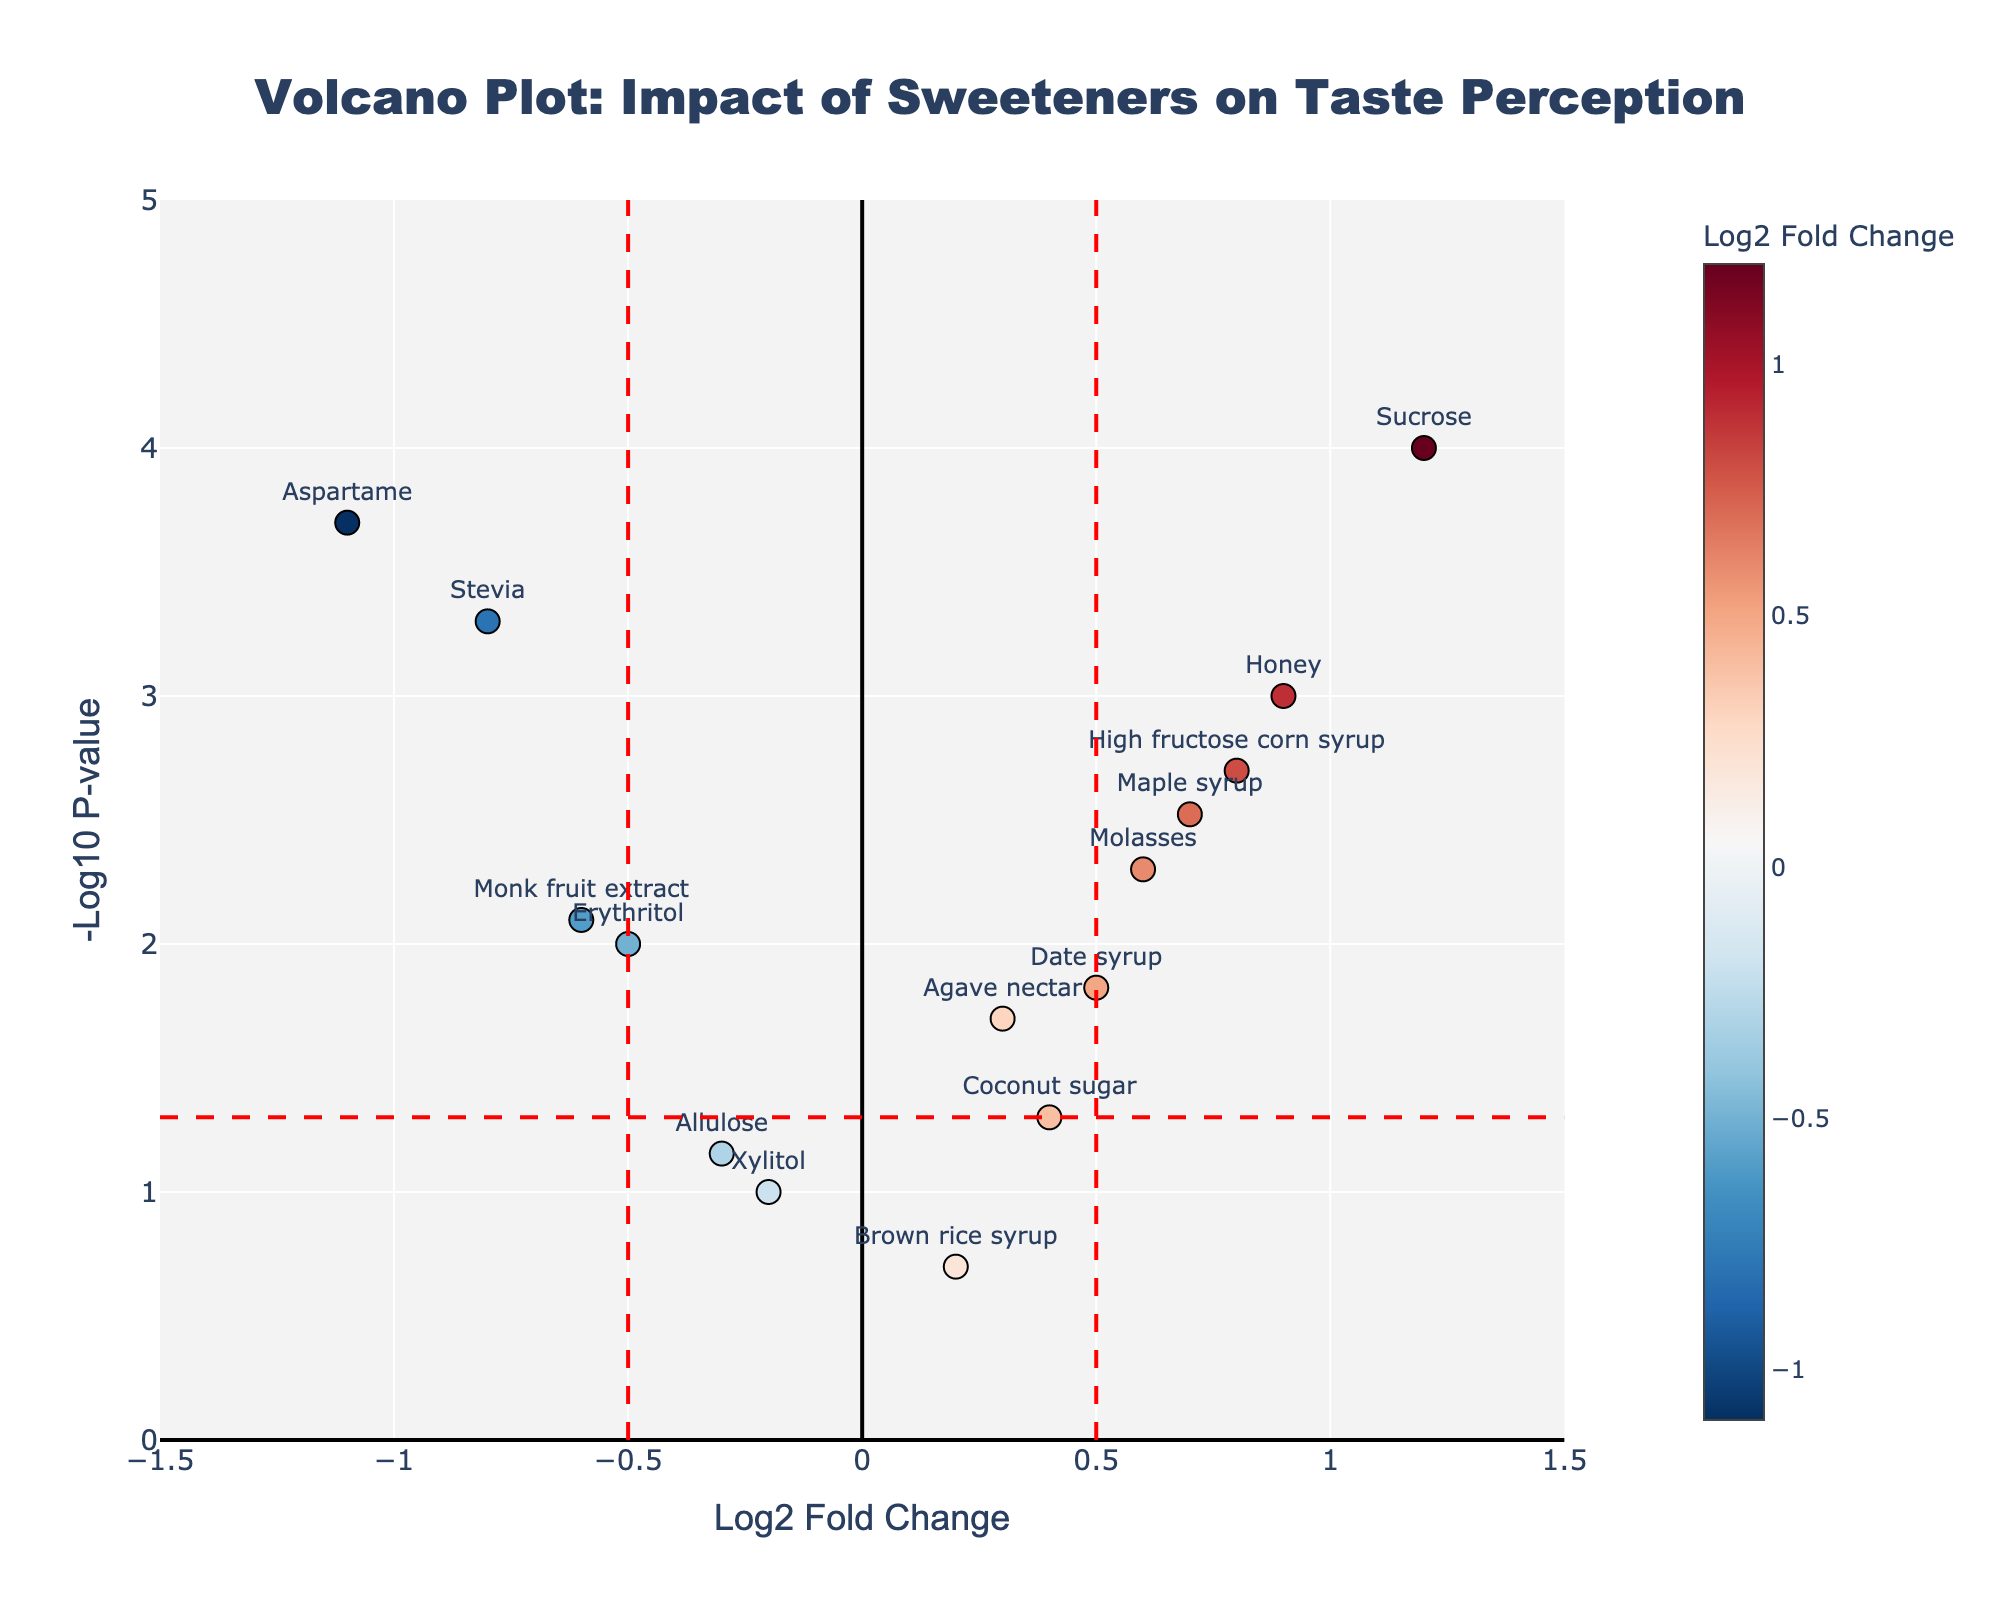What's the highest -log10 p-value shown in the plot? The -log10 p-value is represented on the y-axis. The highest point on this axis will be the maximum value.
Answer: 4 Which sweetener has the most significant positive impact on taste perception? A positive impact on taste perception is shown on the right side (positive log2 fold change) and most significant on the highest point on the y-axis. The sweetener at the highest point on the right side is Sucrose.
Answer: Sucrose Which sweeteners have a statistically significant negative impact on taste perception? Statistically significant points are above the horizontal red dashed line. Those on the left side (negative log2 fold change) are Stevia, Aspartame, Monk fruit extract, and Erythritol.
Answer: Stevia, Aspartame, Monk fruit extract, Erythritol How many sweeteners have a log2 fold change greater than 0.5? Identify points to the right of the vertical red dashed line at 0.5.
Answer: 5 Which sweetener with a negative impact has the lowest p-value? Look at the points on the left (negative log2 fold change) and then check for the highest -log10 p-value among them.
Answer: Aspartame What is the log2 fold change for Honey? Locate the point labeled "Honey" and read its x-axis value.
Answer: 0.9 Which sweetener lies closest to the origin (0,0) point on the plot? Identify the point that is closest to the intersection of the x and y axes (0,0).
Answer: Brown rice syrup How many sweeteners have a statistically significant p-value (p < 0.05)? Count the points above the horizontal red dashed line.
Answer: 12 What is the p-value for Coconut sugar? Locate the point labeled "Coconut sugar" and read its y-axis value, then convert -log10 p-value back to p-value.
Answer: 0.05 Compare the log2 fold changes of Date syrup and Maple syrup. Which one is higher? Locate both points and compare their x-axis values.
Answer: Date syrup 